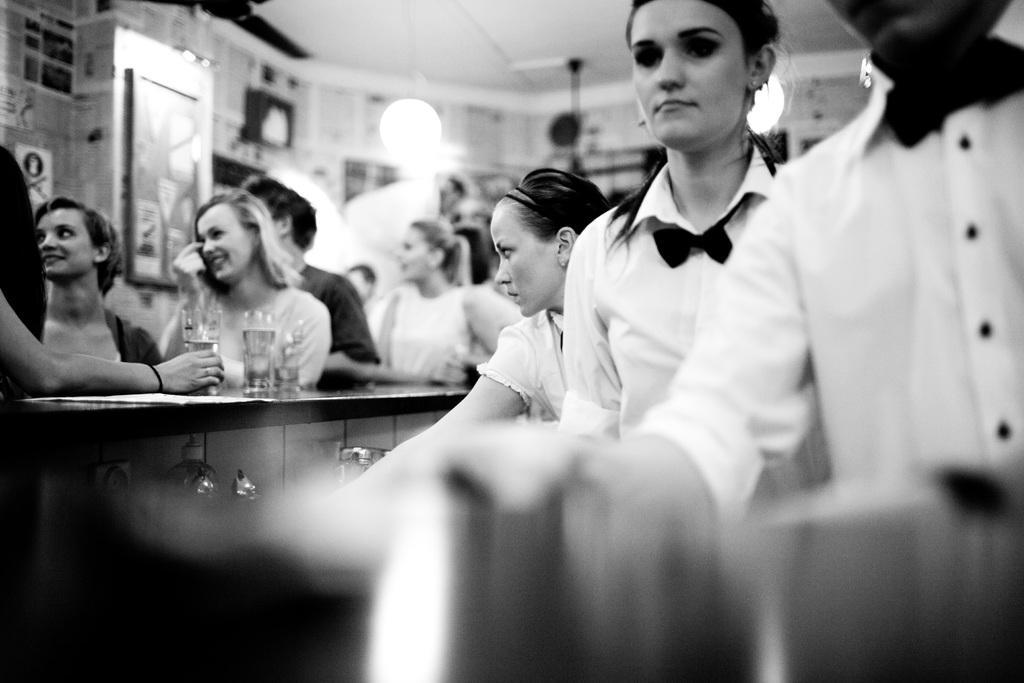Can you describe this image briefly? This picture might be taken inside the room. In this image, we can see group of people are in front of the table, on that table, we can see some wine glasses. At the top, we can see a fan. 